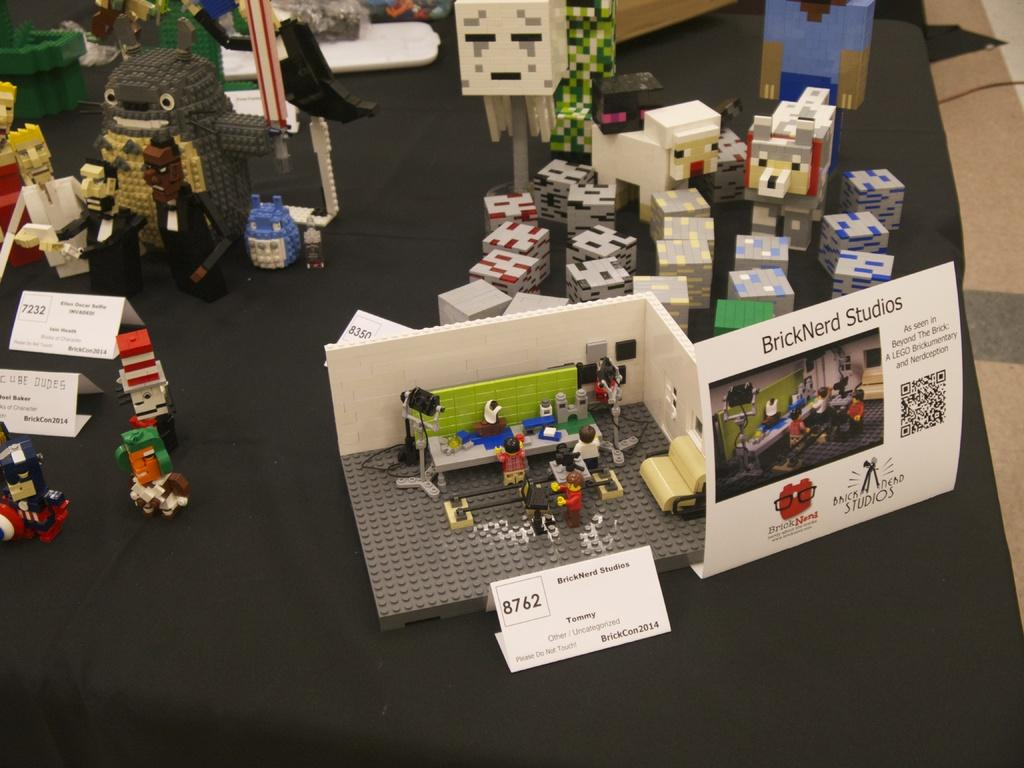What type of objects are in the image? There are toys in the image. Can you describe the appearance of the toys? The toys look like building blocks. What else can be seen on the table in the image? There are white color price boards on the table. How does the wealth of the person owning the toys compare to the vein in the image? There is no information about the wealth of the person owning the toys or any vein present in the image, so it is not possible to make a comparison. 